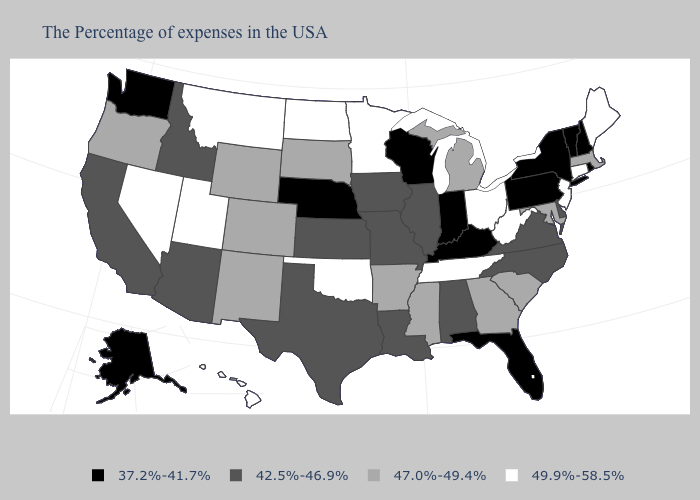What is the value of Nebraska?
Give a very brief answer. 37.2%-41.7%. Does Minnesota have a higher value than Mississippi?
Quick response, please. Yes. Which states have the lowest value in the Northeast?
Keep it brief. Rhode Island, New Hampshire, Vermont, New York, Pennsylvania. Among the states that border Nebraska , does Iowa have the lowest value?
Give a very brief answer. Yes. What is the value of Florida?
Answer briefly. 37.2%-41.7%. Which states have the lowest value in the USA?
Quick response, please. Rhode Island, New Hampshire, Vermont, New York, Pennsylvania, Florida, Kentucky, Indiana, Wisconsin, Nebraska, Washington, Alaska. What is the highest value in states that border South Dakota?
Give a very brief answer. 49.9%-58.5%. Does Maine have the highest value in the Northeast?
Write a very short answer. Yes. What is the value of California?
Give a very brief answer. 42.5%-46.9%. Name the states that have a value in the range 47.0%-49.4%?
Give a very brief answer. Massachusetts, Maryland, South Carolina, Georgia, Michigan, Mississippi, Arkansas, South Dakota, Wyoming, Colorado, New Mexico, Oregon. What is the value of West Virginia?
Quick response, please. 49.9%-58.5%. How many symbols are there in the legend?
Quick response, please. 4. Name the states that have a value in the range 37.2%-41.7%?
Write a very short answer. Rhode Island, New Hampshire, Vermont, New York, Pennsylvania, Florida, Kentucky, Indiana, Wisconsin, Nebraska, Washington, Alaska. What is the value of New Mexico?
Be succinct. 47.0%-49.4%. Which states have the lowest value in the West?
Keep it brief. Washington, Alaska. 